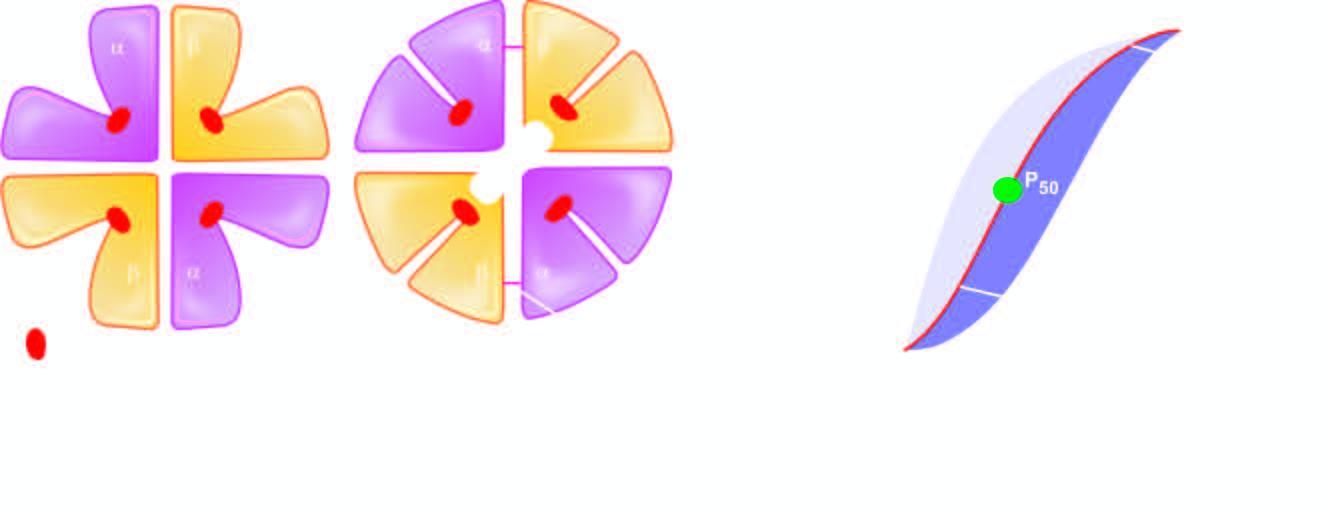s the shift of the curve to higher oxygen delivery affected by acidic ph?
Answer the question using a single word or phrase. Yes 